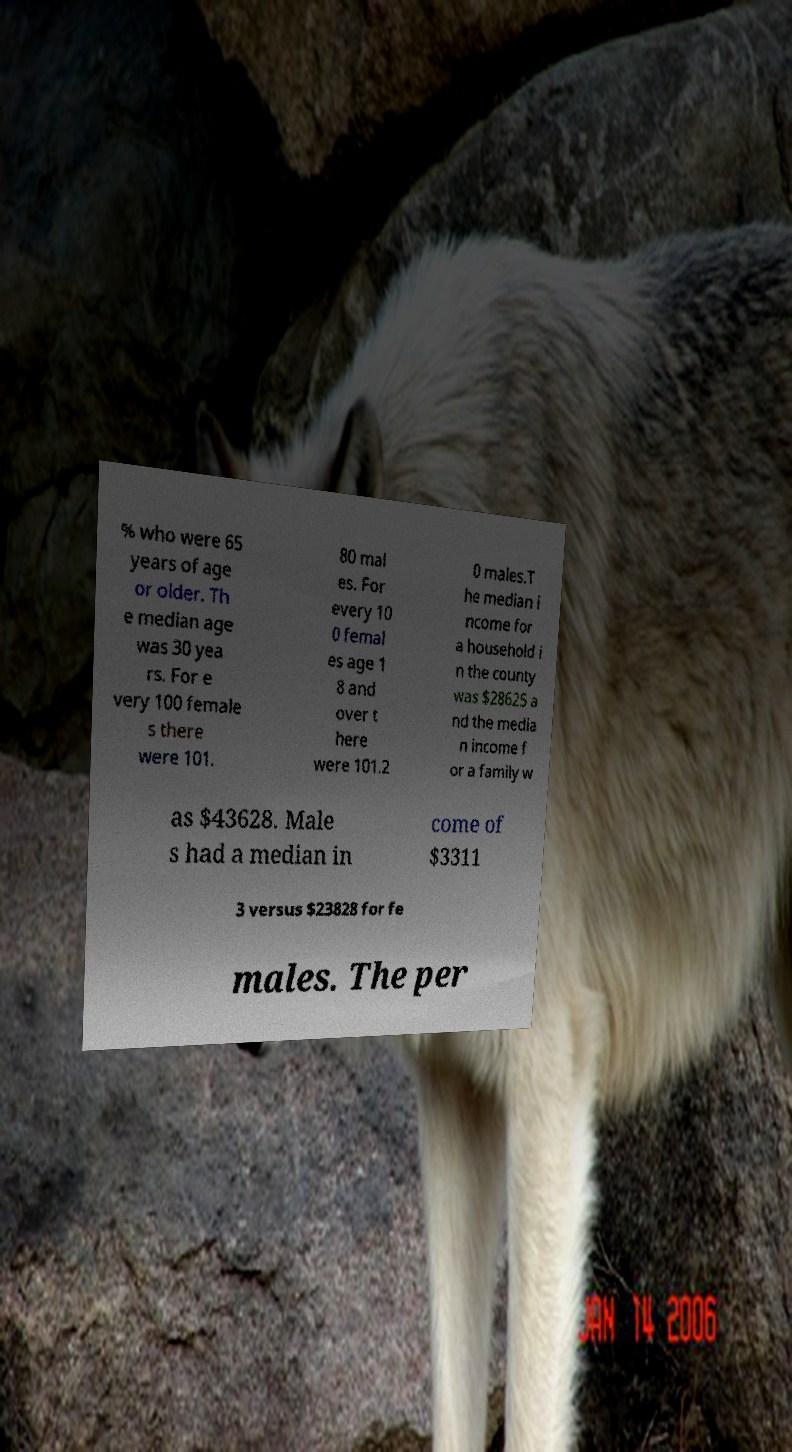Can you accurately transcribe the text from the provided image for me? % who were 65 years of age or older. Th e median age was 30 yea rs. For e very 100 female s there were 101. 80 mal es. For every 10 0 femal es age 1 8 and over t here were 101.2 0 males.T he median i ncome for a household i n the county was $28625 a nd the media n income f or a family w as $43628. Male s had a median in come of $3311 3 versus $23828 for fe males. The per 